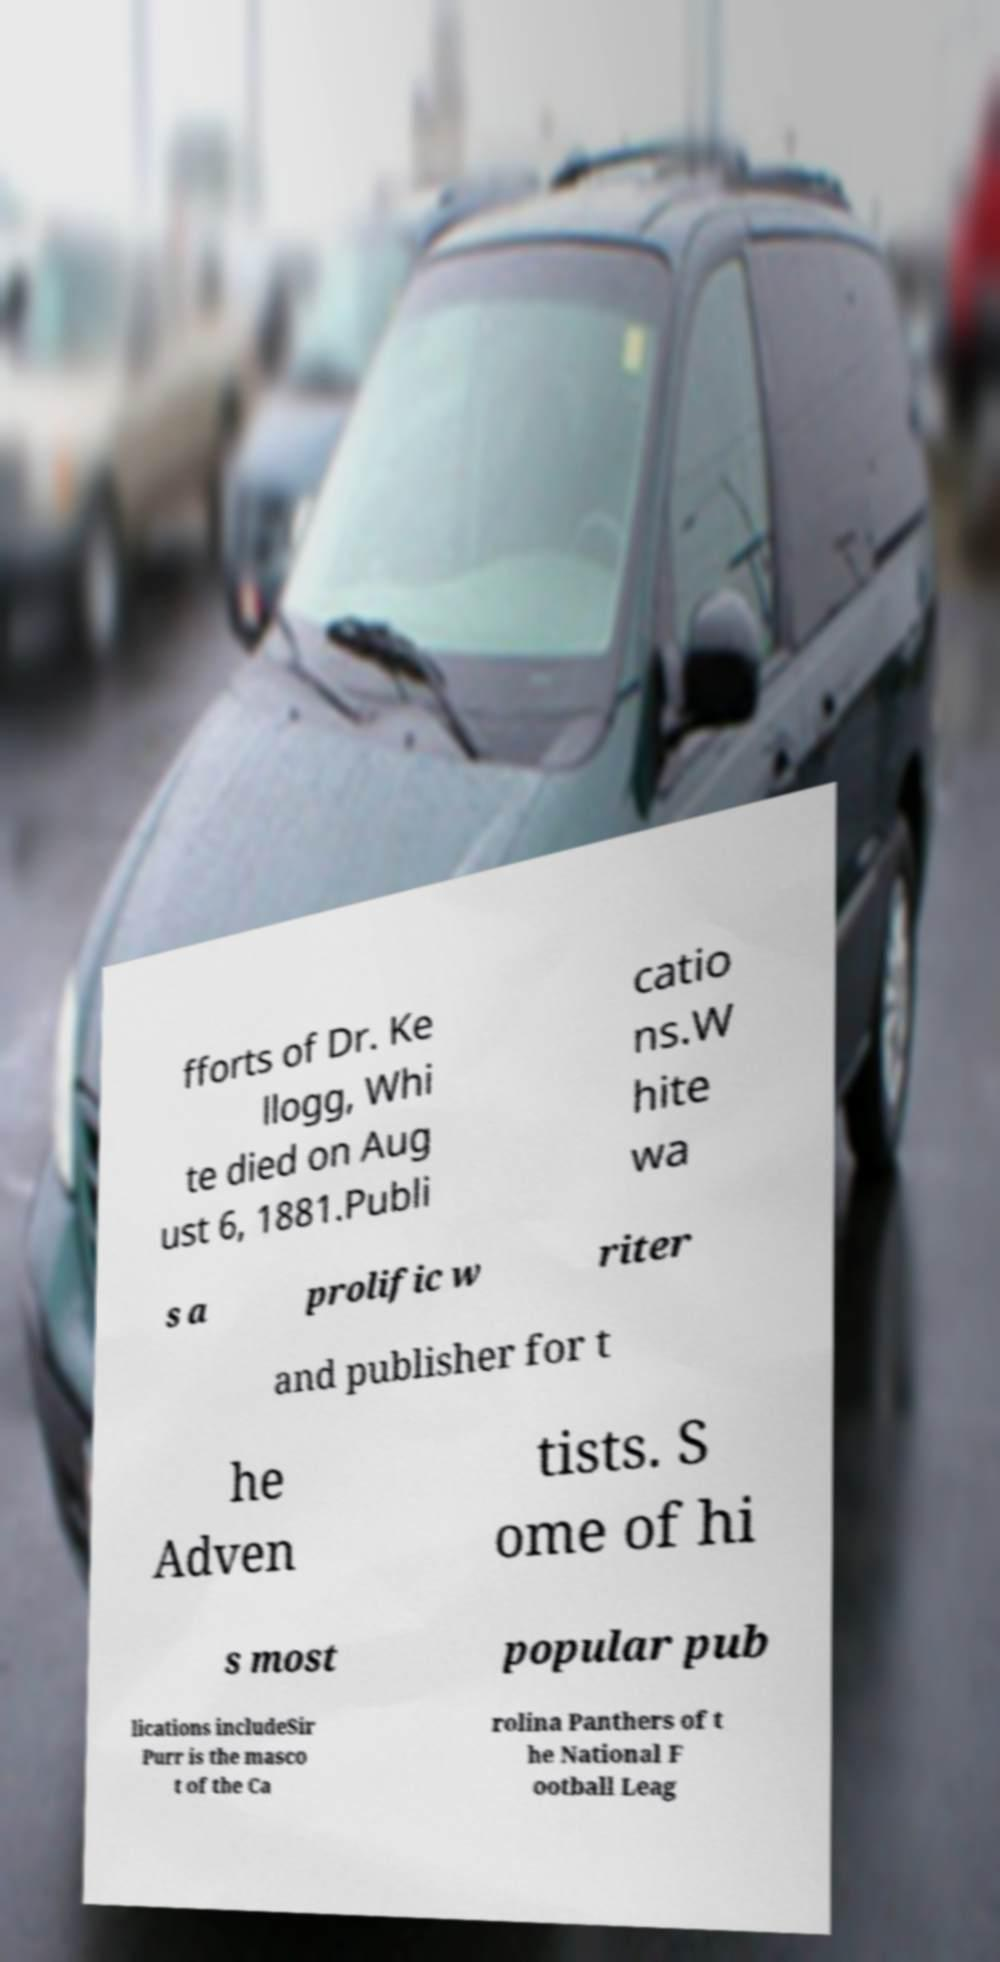Please read and relay the text visible in this image. What does it say? fforts of Dr. Ke llogg, Whi te died on Aug ust 6, 1881.Publi catio ns.W hite wa s a prolific w riter and publisher for t he Adven tists. S ome of hi s most popular pub lications includeSir Purr is the masco t of the Ca rolina Panthers of t he National F ootball Leag 